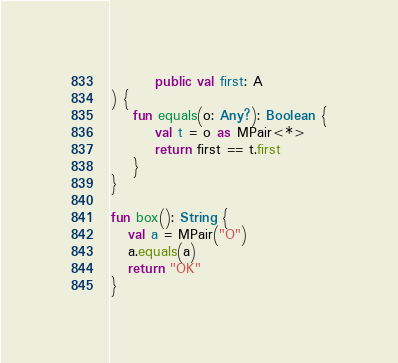<code> <loc_0><loc_0><loc_500><loc_500><_Kotlin_>        public val first: A
) {
    fun equals(o: Any?): Boolean {
        val t = o as MPair<*>
        return first == t.first
    }
}

fun box(): String {
   val a = MPair("O")
   a.equals(a)
   return "OK"
}</code> 